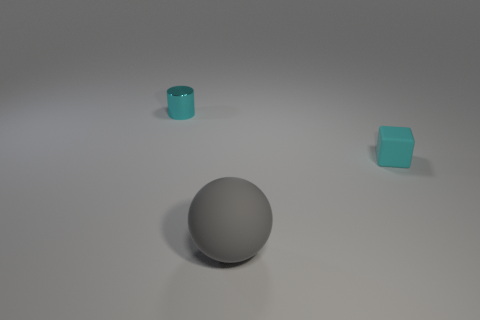Add 1 tiny cyan matte cubes. How many objects exist? 4 Subtract all blocks. How many objects are left? 2 Add 1 red rubber blocks. How many red rubber blocks exist? 1 Subtract 0 red balls. How many objects are left? 3 Subtract all small blue cylinders. Subtract all cylinders. How many objects are left? 2 Add 2 tiny cyan metal cylinders. How many tiny cyan metal cylinders are left? 3 